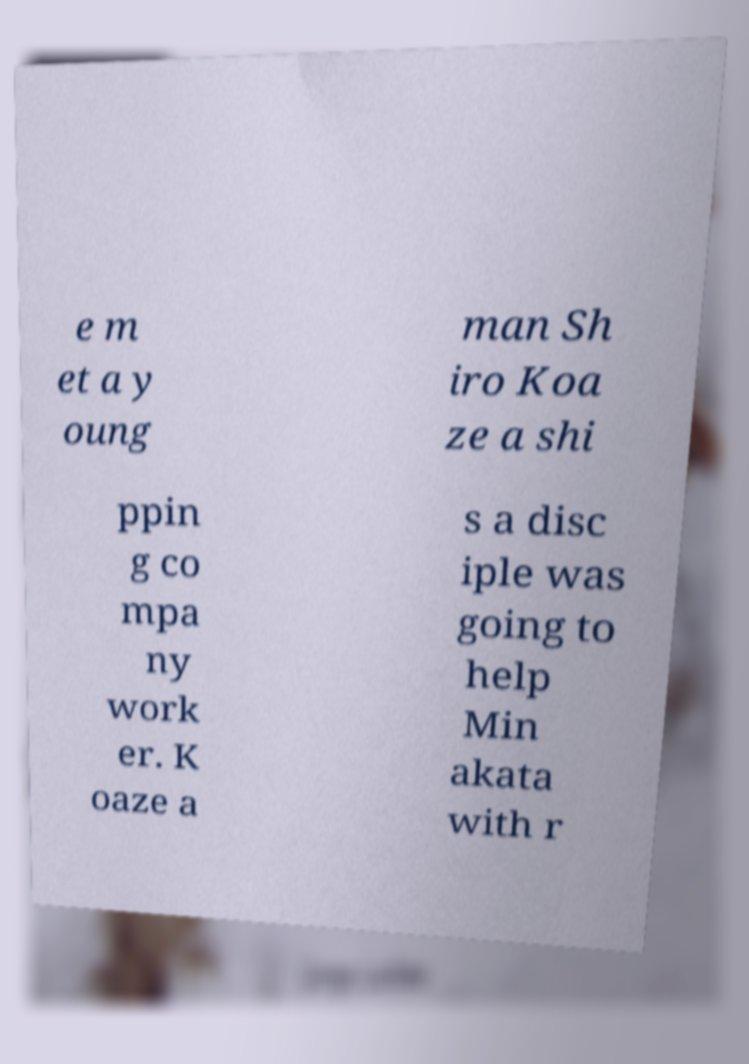Could you extract and type out the text from this image? e m et a y oung man Sh iro Koa ze a shi ppin g co mpa ny work er. K oaze a s a disc iple was going to help Min akata with r 